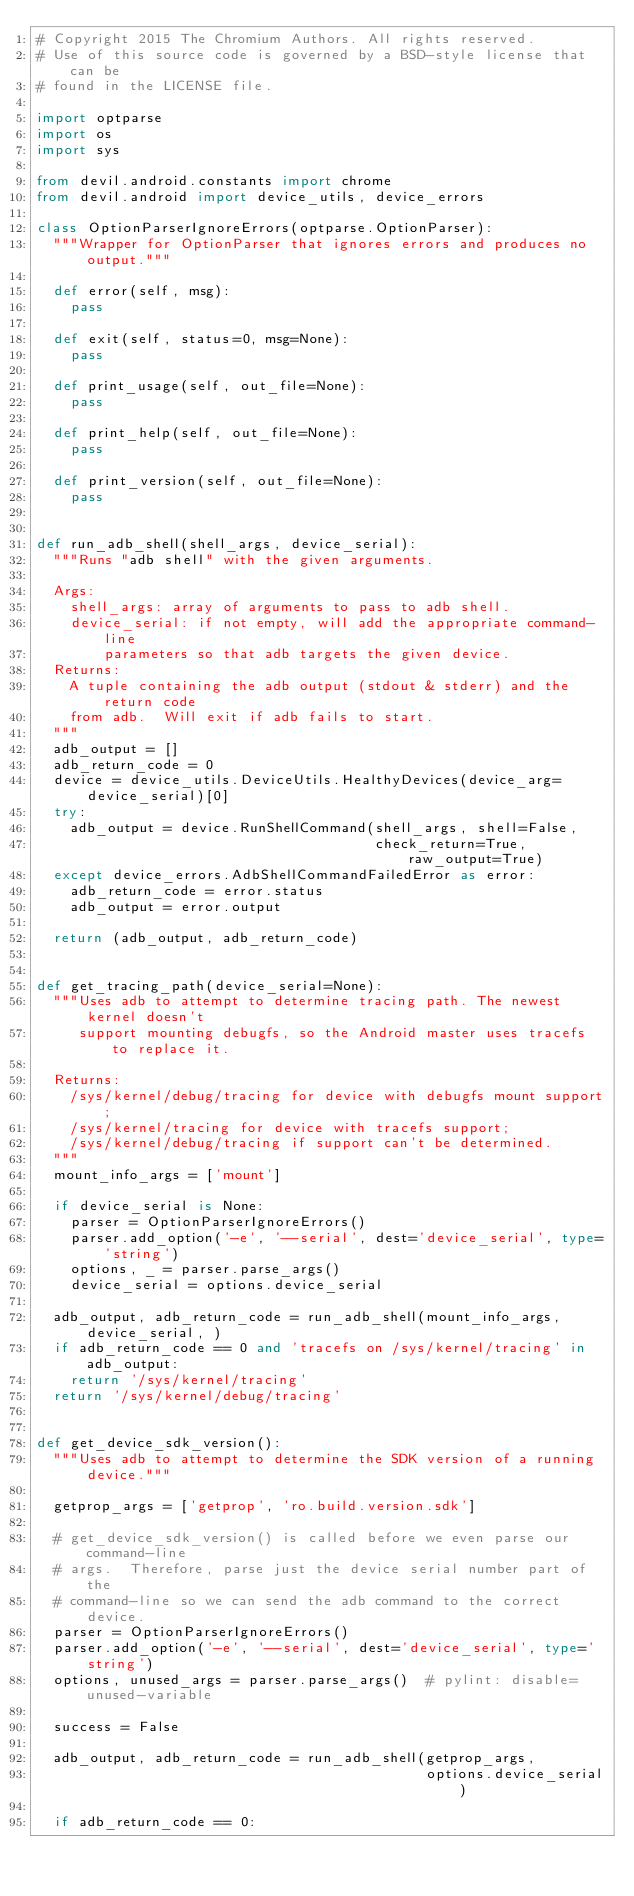Convert code to text. <code><loc_0><loc_0><loc_500><loc_500><_Python_># Copyright 2015 The Chromium Authors. All rights reserved.
# Use of this source code is governed by a BSD-style license that can be
# found in the LICENSE file.

import optparse
import os
import sys

from devil.android.constants import chrome
from devil.android import device_utils, device_errors

class OptionParserIgnoreErrors(optparse.OptionParser):
  """Wrapper for OptionParser that ignores errors and produces no output."""

  def error(self, msg):
    pass

  def exit(self, status=0, msg=None):
    pass

  def print_usage(self, out_file=None):
    pass

  def print_help(self, out_file=None):
    pass

  def print_version(self, out_file=None):
    pass


def run_adb_shell(shell_args, device_serial):
  """Runs "adb shell" with the given arguments.

  Args:
    shell_args: array of arguments to pass to adb shell.
    device_serial: if not empty, will add the appropriate command-line
        parameters so that adb targets the given device.
  Returns:
    A tuple containing the adb output (stdout & stderr) and the return code
    from adb.  Will exit if adb fails to start.
  """
  adb_output = []
  adb_return_code = 0
  device = device_utils.DeviceUtils.HealthyDevices(device_arg=device_serial)[0]
  try:
    adb_output = device.RunShellCommand(shell_args, shell=False,
                                        check_return=True, raw_output=True)
  except device_errors.AdbShellCommandFailedError as error:
    adb_return_code = error.status
    adb_output = error.output

  return (adb_output, adb_return_code)


def get_tracing_path(device_serial=None):
  """Uses adb to attempt to determine tracing path. The newest kernel doesn't
     support mounting debugfs, so the Android master uses tracefs to replace it.

  Returns:
    /sys/kernel/debug/tracing for device with debugfs mount support;
    /sys/kernel/tracing for device with tracefs support;
    /sys/kernel/debug/tracing if support can't be determined.
  """
  mount_info_args = ['mount']

  if device_serial is None:
    parser = OptionParserIgnoreErrors()
    parser.add_option('-e', '--serial', dest='device_serial', type='string')
    options, _ = parser.parse_args()
    device_serial = options.device_serial

  adb_output, adb_return_code = run_adb_shell(mount_info_args, device_serial, )
  if adb_return_code == 0 and 'tracefs on /sys/kernel/tracing' in adb_output:
    return '/sys/kernel/tracing'
  return '/sys/kernel/debug/tracing'


def get_device_sdk_version():
  """Uses adb to attempt to determine the SDK version of a running device."""

  getprop_args = ['getprop', 'ro.build.version.sdk']

  # get_device_sdk_version() is called before we even parse our command-line
  # args.  Therefore, parse just the device serial number part of the
  # command-line so we can send the adb command to the correct device.
  parser = OptionParserIgnoreErrors()
  parser.add_option('-e', '--serial', dest='device_serial', type='string')
  options, unused_args = parser.parse_args()  # pylint: disable=unused-variable

  success = False

  adb_output, adb_return_code = run_adb_shell(getprop_args,
                                              options.device_serial)

  if adb_return_code == 0:</code> 